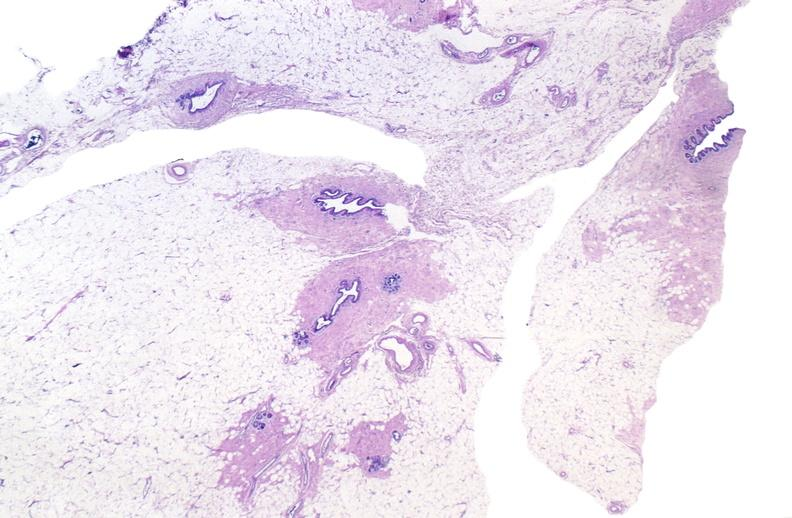what does this image show?
Answer the question using a single word or phrase. Normal breast 